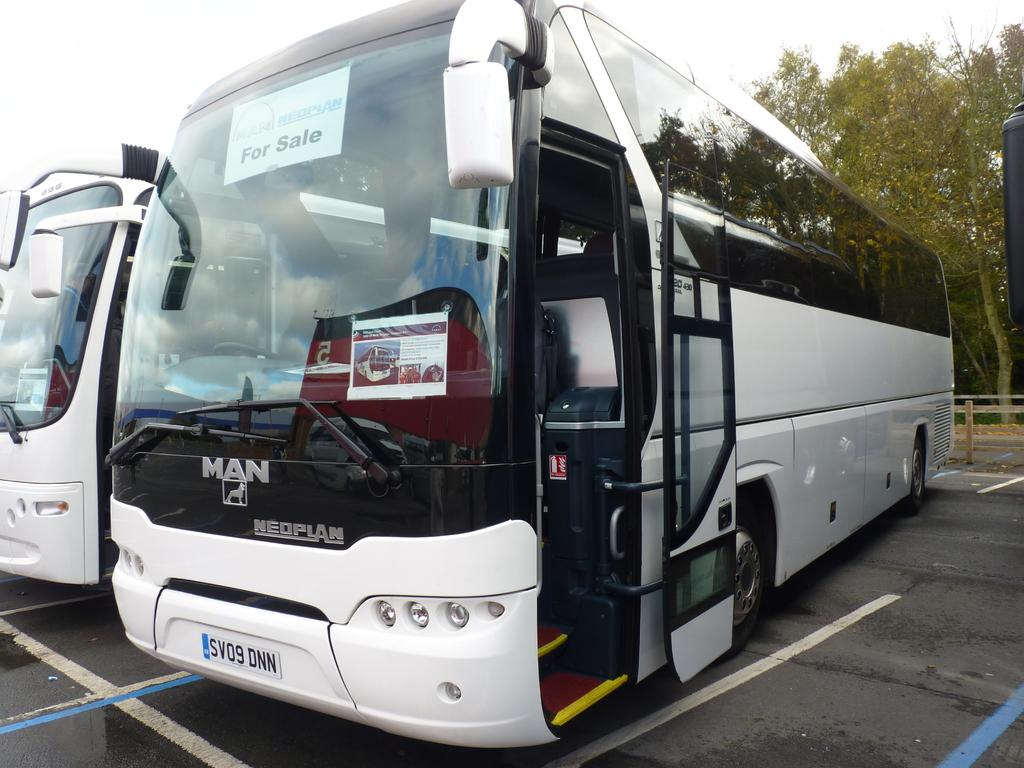What type of vehicles are present in the image? There are buses in the image. Where are the buses located? The buses are parked on the road. What can be seen in the background of the image? There are trees visible in the image. What type of class is being taught in the wilderness in the image? There is no class or wilderness present in the image; it features buses parked on the road with trees in the background. 